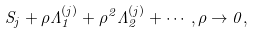<formula> <loc_0><loc_0><loc_500><loc_500>S _ { j } + \rho \Lambda _ { 1 } ^ { ( j ) } + \rho ^ { 2 } \Lambda _ { 2 } ^ { ( j ) } + \cdots , \rho \to 0 ,</formula> 